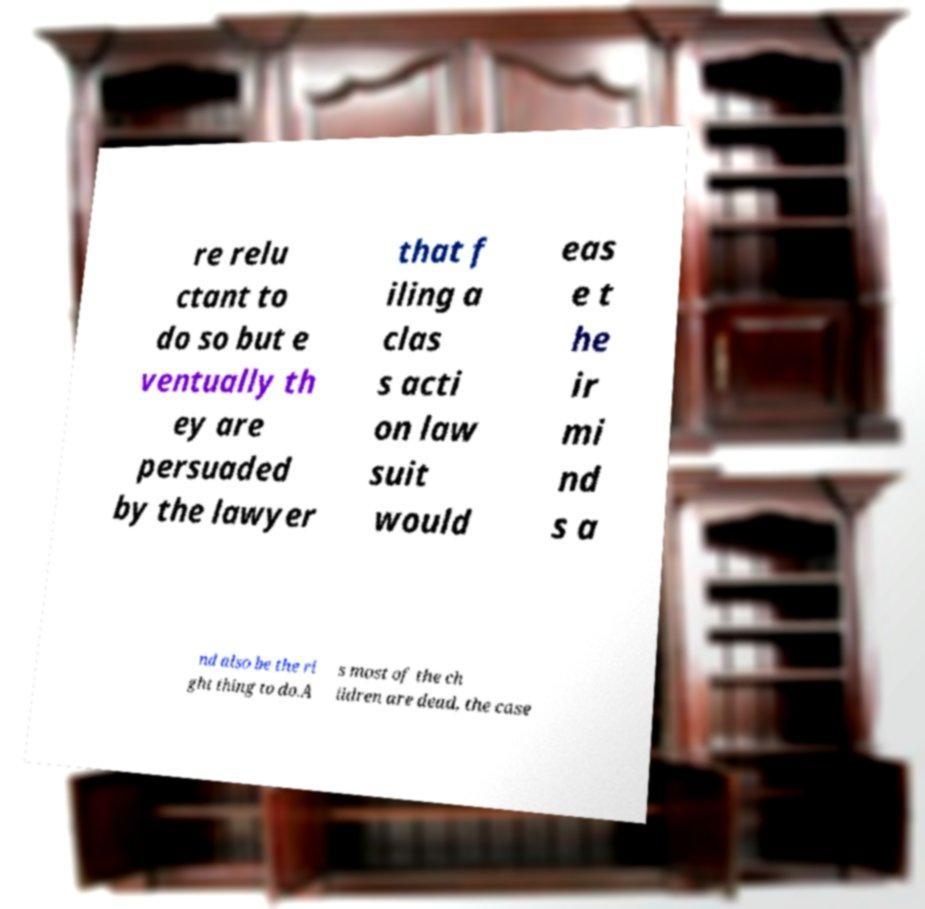Could you assist in decoding the text presented in this image and type it out clearly? re relu ctant to do so but e ventually th ey are persuaded by the lawyer that f iling a clas s acti on law suit would eas e t he ir mi nd s a nd also be the ri ght thing to do.A s most of the ch ildren are dead, the case 